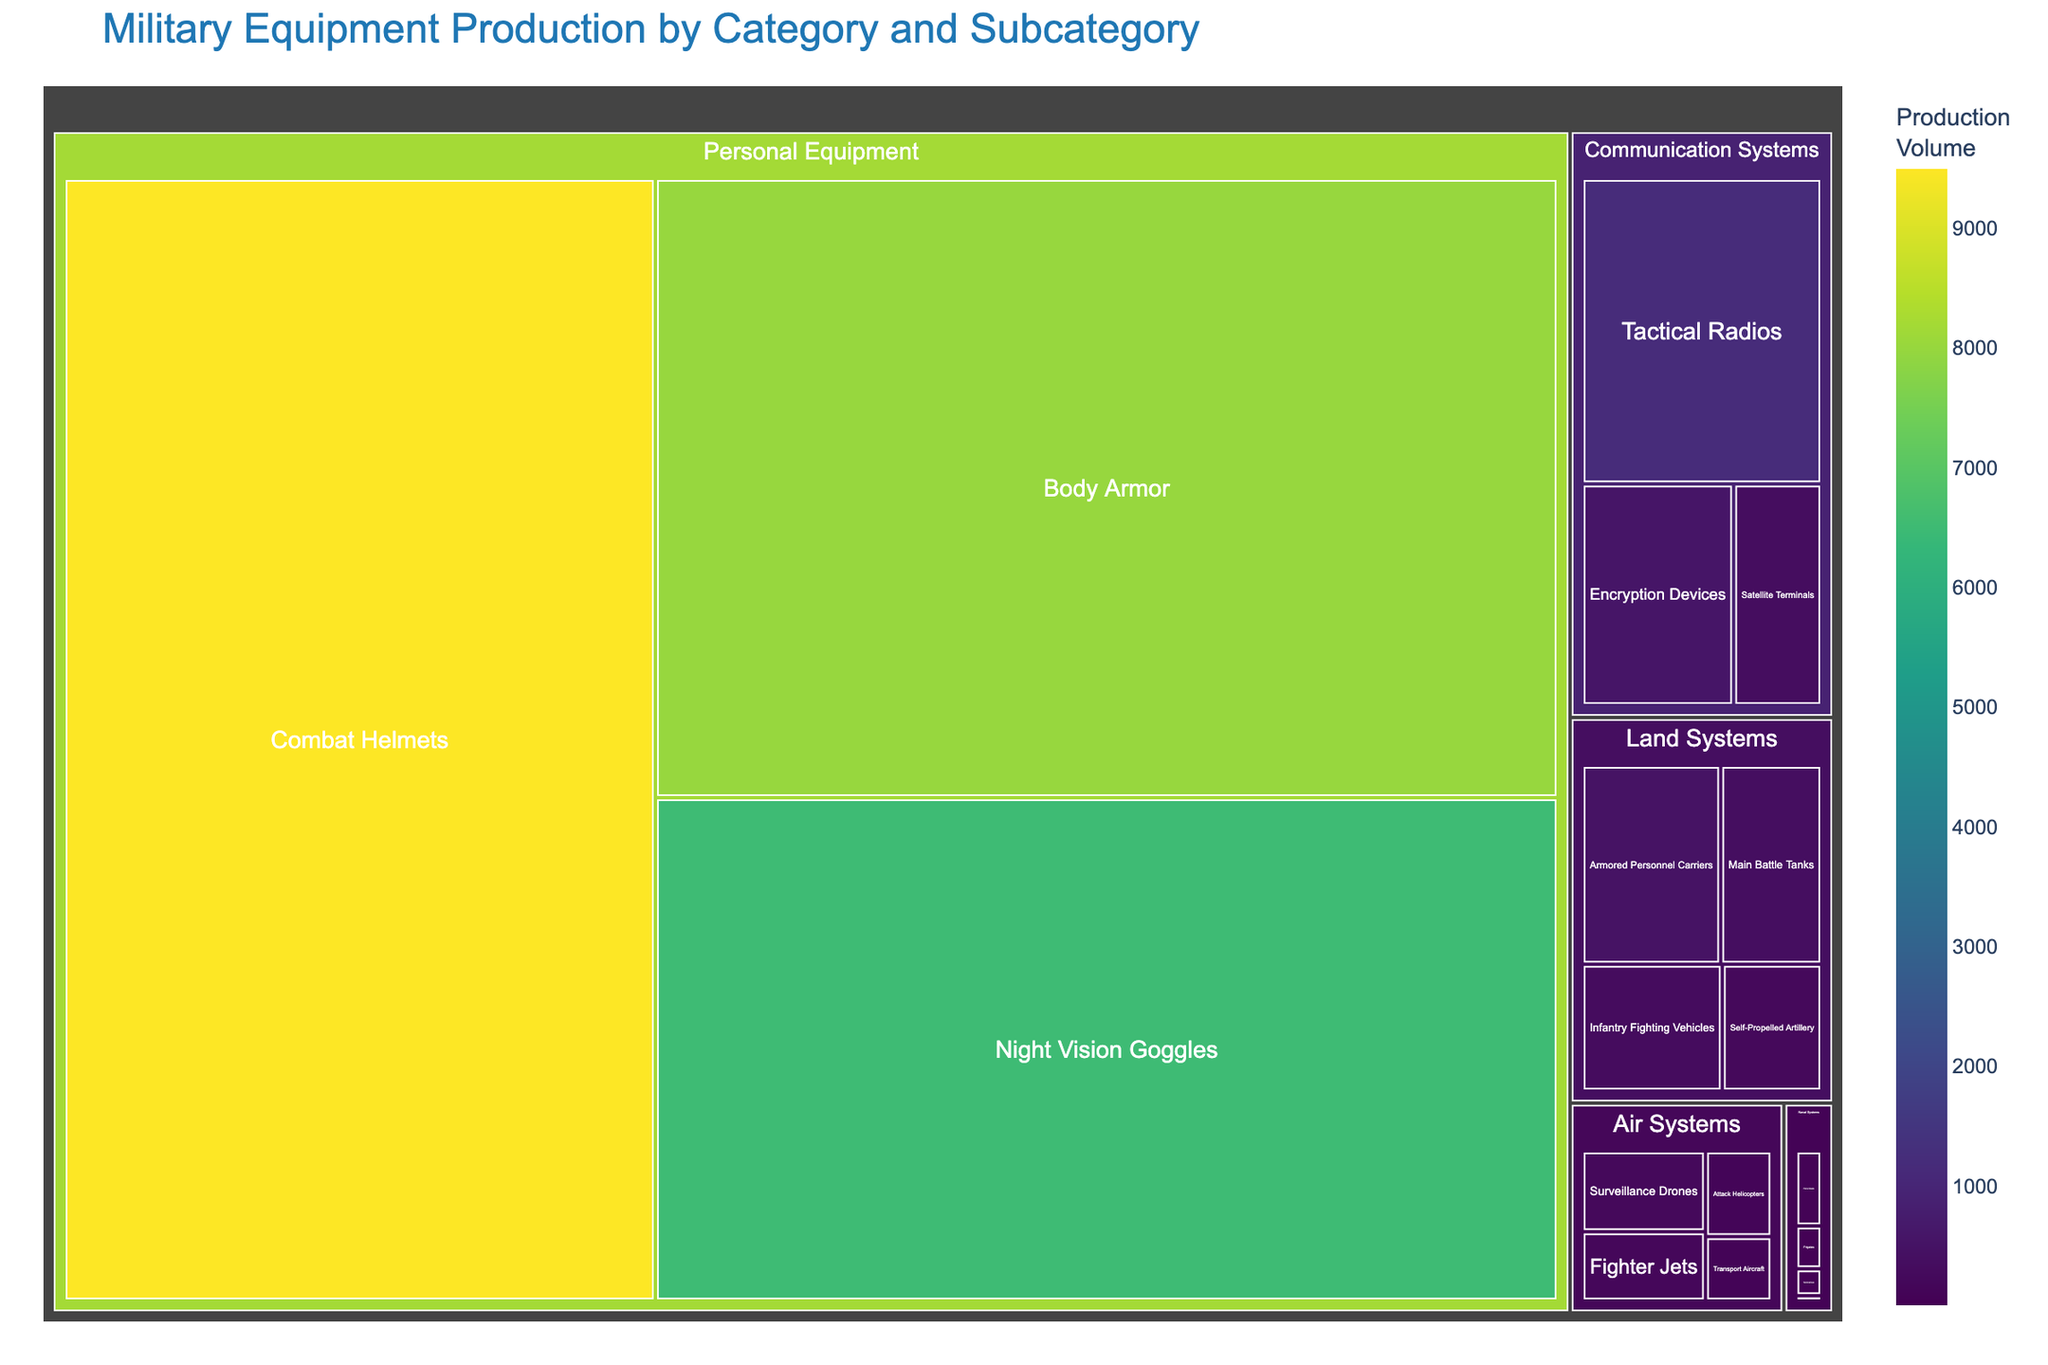What category has the highest total production? Sum the values for each category and compare them. 'Personal Equipment' has the highest with a combined total of 24,000 units (8000+6500+9500).
Answer: Personal Equipment What is the total production for 'Land Systems'? Add the production values for all subcategories under 'Land Systems': 350 (Main Battle Tanks) + 480 (Armored Personnel Carriers) + 220 (Self-Propelled Artillery) + 310 (Infantry Fighting Vehicles) = 1360.
Answer: 1360 How many subcategories are there under 'Air Systems'? Count the different subcategories listed under 'Air Systems': Fighter Jets, Transport Aircraft, Attack Helicopters, Surveillance Drones. There are 4 subcategories.
Answer: 4 Which subcategory has the lowest production, and what is its value? Identify the subcategory with the least value in the entire treemap. 'Aircraft Carriers' in 'Naval Systems' has the lowest production with 5 units.
Answer: Aircraft Carriers, 5 Is the production of 'Encryption Devices' greater than that of 'Satellite Terminals' in Communication Systems? Compare the values of 'Encryption Devices' (550) and 'Satellite Terminals' (320). '550' is greater than '320'.
Answer: Yes What's the combined production of 'Communication Systems' and 'Naval Systems'? Add the total production values of the two categories. Communication Systems: 1200 (Tactical Radios) + 320 (Satellite Terminals) + 550 (Encryption Devices) = 2070. Naval Systems: 40 (Frigates) + 25 (Submarines) + 70 (Patrol Boats) + 5 (Aircraft Carriers) = 140. Combined: 2070 + 140 = 2210.
Answer: 2210 Which subcategory has the highest production in 'Air Systems'? Compare the production values of all subcategories under 'Air Systems'. 'Surveillance Drones' has the highest with 210 units.
Answer: Surveillance Drones What is the color used for the highest production subcategory, 'Combat Helmets'? Look at the color represented for 'Combat Helmets' in the treemap. In the color continuous scale 'viridis', it is represented by the darkest color.
Answer: Darkest color What's the difference in production between 'Main Battle Tanks' and 'Fighter Jets'? Subtract the production value of 'Fighter Jets' (180) from that of 'Main Battle Tanks' (350). 350 - 180 = 170.
Answer: 170 